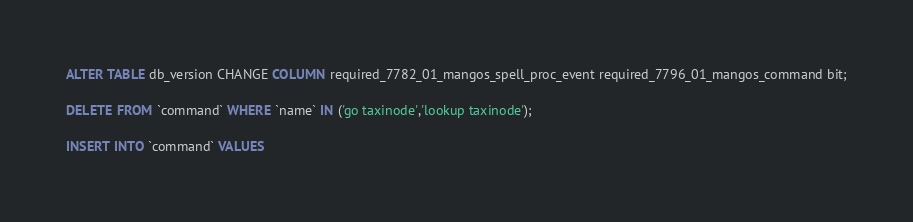Convert code to text. <code><loc_0><loc_0><loc_500><loc_500><_SQL_>ALTER TABLE db_version CHANGE COLUMN required_7782_01_mangos_spell_proc_event required_7796_01_mangos_command bit;

DELETE FROM `command` WHERE `name` IN ('go taxinode','lookup taxinode');

INSERT INTO `command` VALUES</code> 